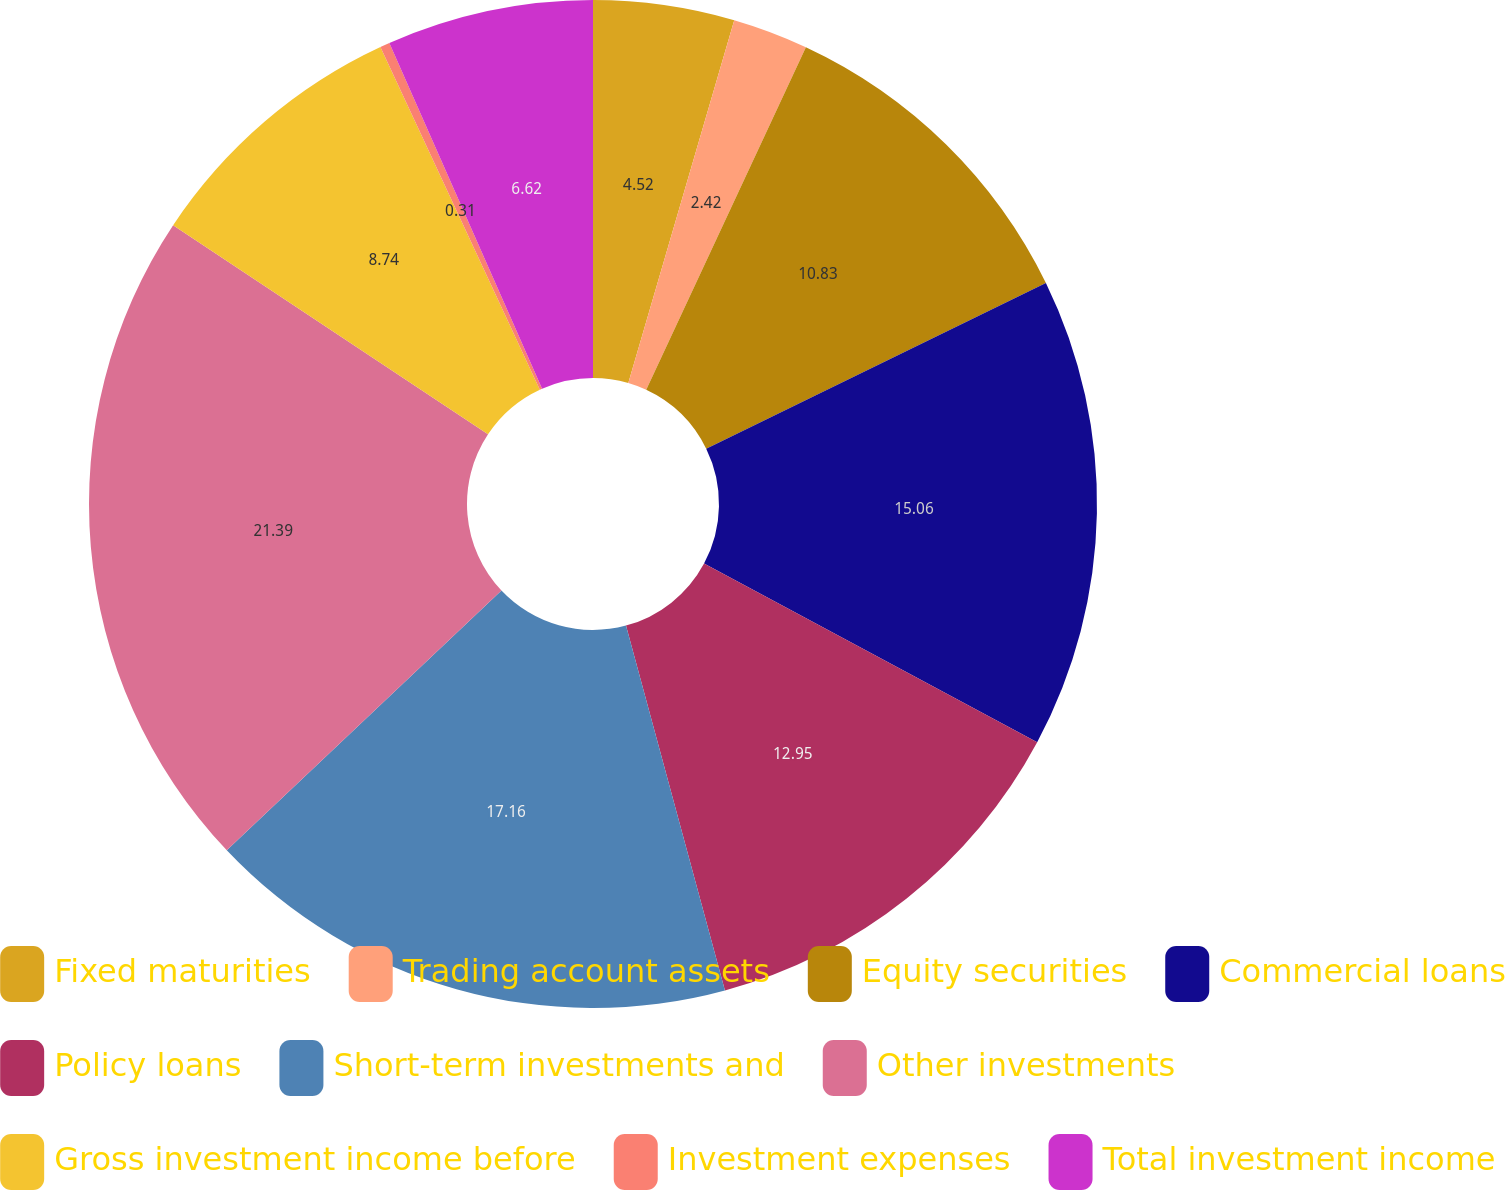Convert chart. <chart><loc_0><loc_0><loc_500><loc_500><pie_chart><fcel>Fixed maturities<fcel>Trading account assets<fcel>Equity securities<fcel>Commercial loans<fcel>Policy loans<fcel>Short-term investments and<fcel>Other investments<fcel>Gross investment income before<fcel>Investment expenses<fcel>Total investment income<nl><fcel>4.52%<fcel>2.42%<fcel>10.83%<fcel>15.06%<fcel>12.95%<fcel>17.16%<fcel>21.38%<fcel>8.74%<fcel>0.31%<fcel>6.62%<nl></chart> 